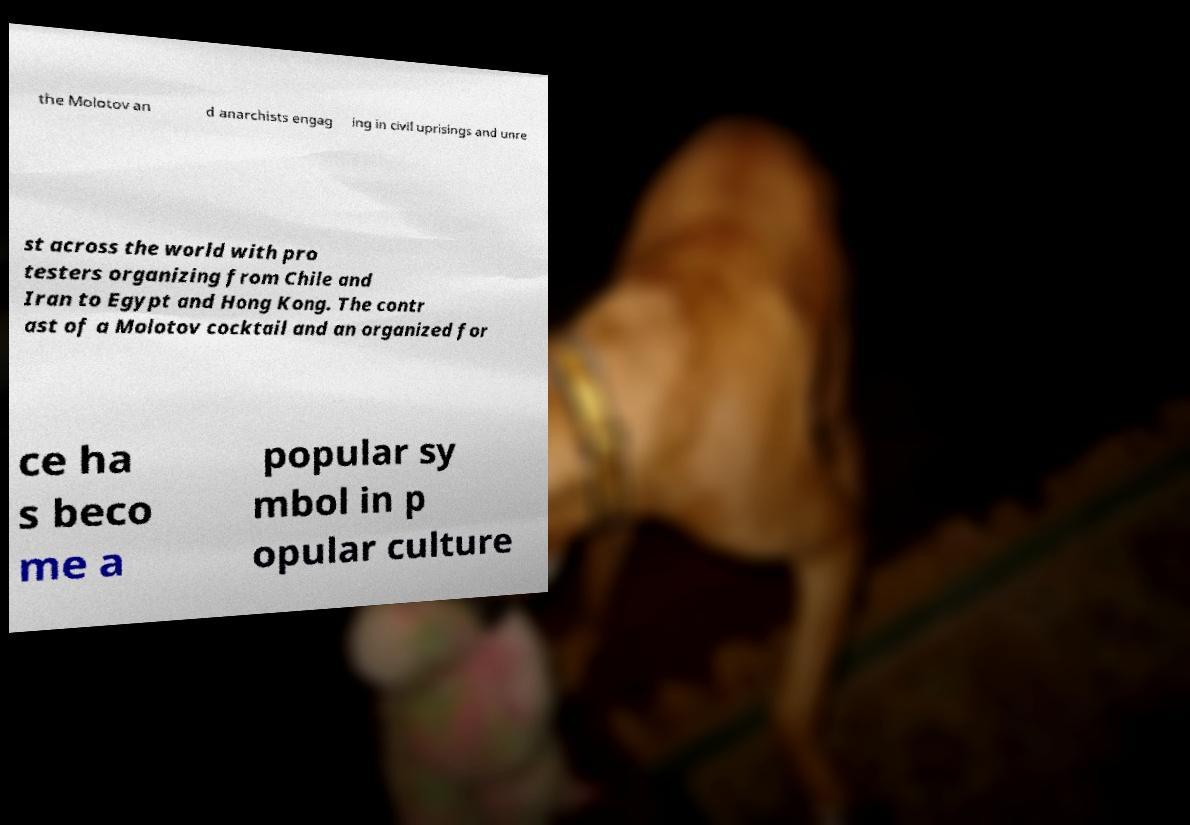For documentation purposes, I need the text within this image transcribed. Could you provide that? the Molotov an d anarchists engag ing in civil uprisings and unre st across the world with pro testers organizing from Chile and Iran to Egypt and Hong Kong. The contr ast of a Molotov cocktail and an organized for ce ha s beco me a popular sy mbol in p opular culture 